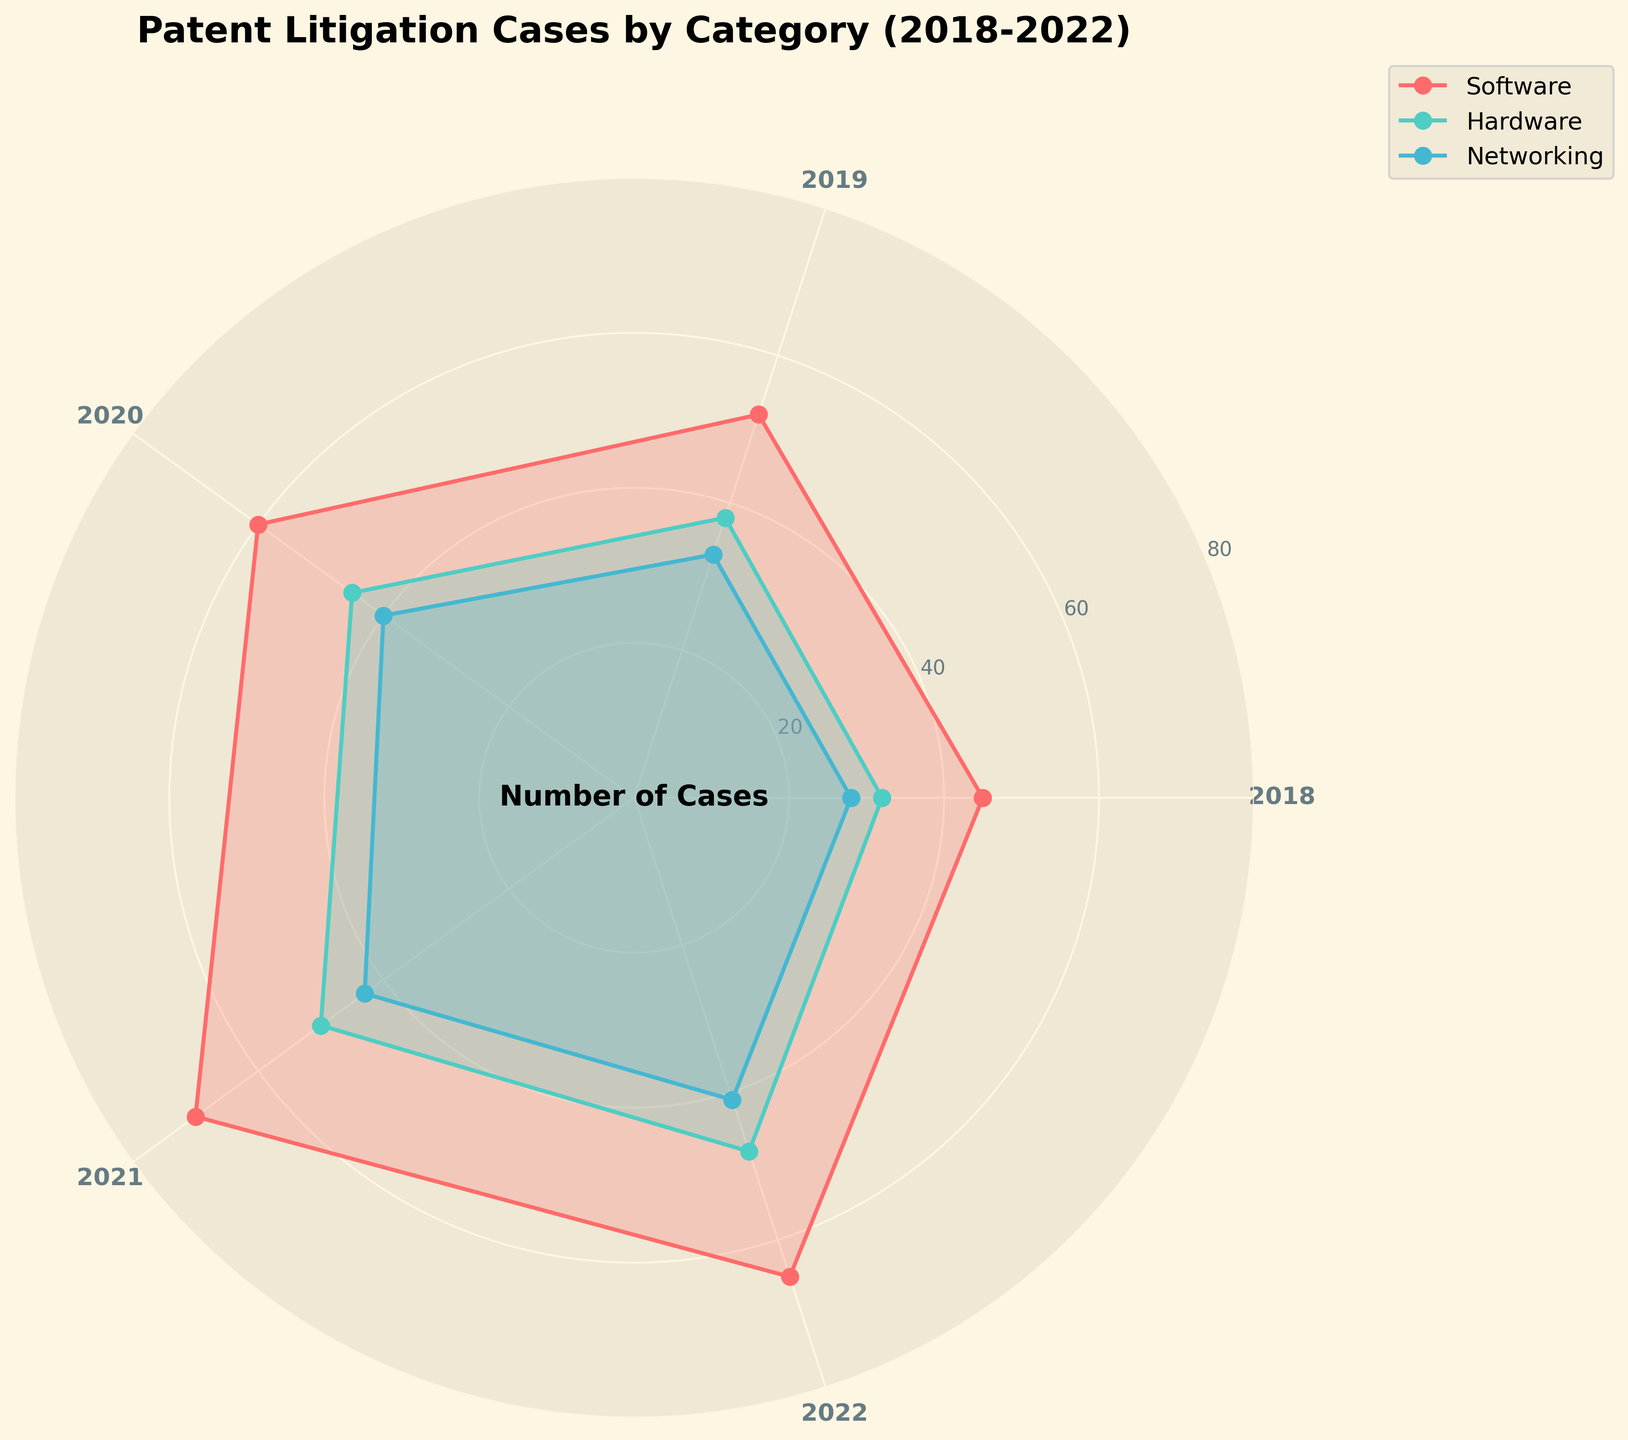What is the title of the figure? The title of the figure is displayed at the top of the rose chart. It provides a summary of what the chart represents.
Answer: Patent Litigation Cases by Category (2018-2022) How many categories are displayed in the chart? The rose chart uses different colors and labels to represent the various categories.
Answer: 3 Which color represents the Networking category? The legend on the figure shows that each category corresponds to a specific color. The color next to the "Networking" label indicates which part of the chart represents Networking.
Answer: Light Blue What is the maximum number of litigation cases in the Hardware category over the years? By examining the peaks of the lines corresponding to the Hardware category (color-coded in the legend), the highest point on the radial axis indicates the maximum number.
Answer: 50 How did the number of litigation cases for Software change from 2018 to 2022? This involves comparing the values at the angular positions corresponding to 2018 and 2022, noting the increase or decrease. The Software category line shows the number of cases going from the starting year to the closing year.
Answer: Increased What is the total number of litigation cases for Networking in the years 2018 and 2020 combined? Add up the values for Networking in the given years. For 2018, it's 28, and for 2020, it's 40.
Answer: 68 Which category had the highest increase in litigation cases from 2018 to 2022? Calculate the increase for each category by subtracting the number of cases in 2018 from the number in 2022. Software: 65-45=20, Hardware: 48-32=16, Networking: 41-28=13.
Answer: Software Did any category experience a decrease in the number of cases from 2021 to 2022? Compare the values for each category for the years 2021 and 2022. A decrease is found if the number in 2022 is less than in 2021. For Software: 70 to 65, a decrease.
Answer: Yes, Software What is the average number of litigation cases in the Software category across all years? Sum the number of cases for Software from 2018 to 2022, then divide by the number of years. (45 + 52 + 60 + 70 + 65) / 5 = 58.4
Answer: 58.4 Which category has the least variation in the number of litigation cases over time? Variation can be understood as the range or the difference between the maximum and minimum values for each category over the years. Software: 70-45=25, Hardware: 50-32=18, Networking: 43-28=15.
Answer: Networking 